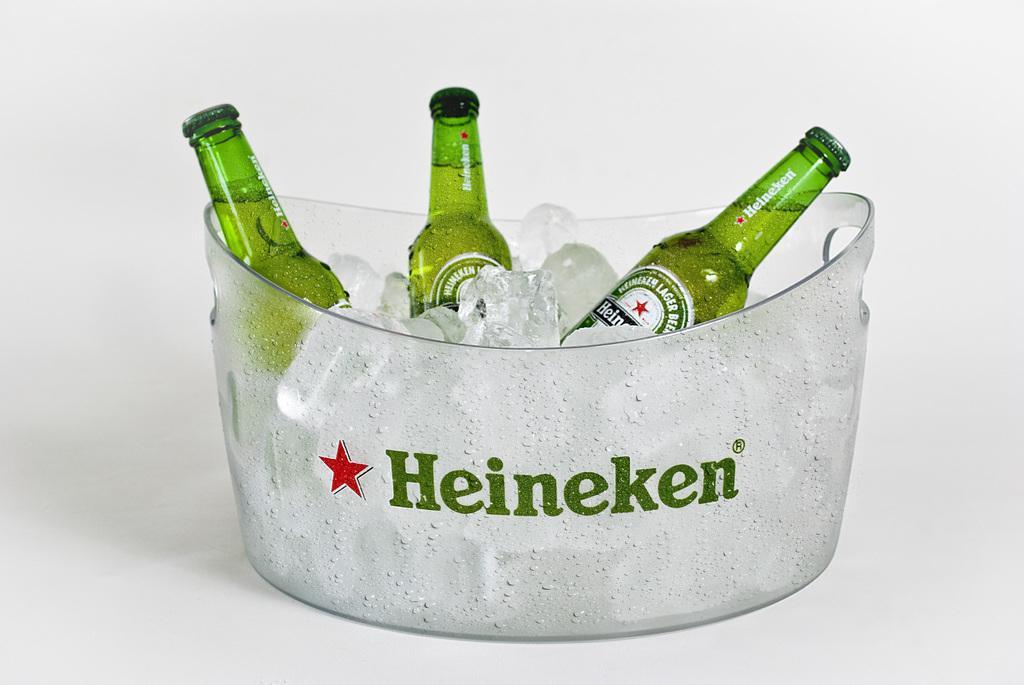How would you summarize this image in a sentence or two? In this image I see 3 bottles and ice in this bowl, I can also see it is written Heineken and a star on this. 